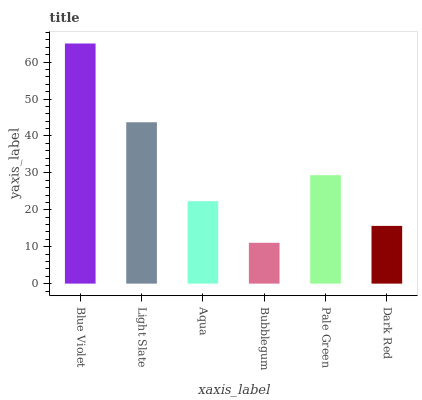Is Bubblegum the minimum?
Answer yes or no. Yes. Is Blue Violet the maximum?
Answer yes or no. Yes. Is Light Slate the minimum?
Answer yes or no. No. Is Light Slate the maximum?
Answer yes or no. No. Is Blue Violet greater than Light Slate?
Answer yes or no. Yes. Is Light Slate less than Blue Violet?
Answer yes or no. Yes. Is Light Slate greater than Blue Violet?
Answer yes or no. No. Is Blue Violet less than Light Slate?
Answer yes or no. No. Is Pale Green the high median?
Answer yes or no. Yes. Is Aqua the low median?
Answer yes or no. Yes. Is Blue Violet the high median?
Answer yes or no. No. Is Light Slate the low median?
Answer yes or no. No. 